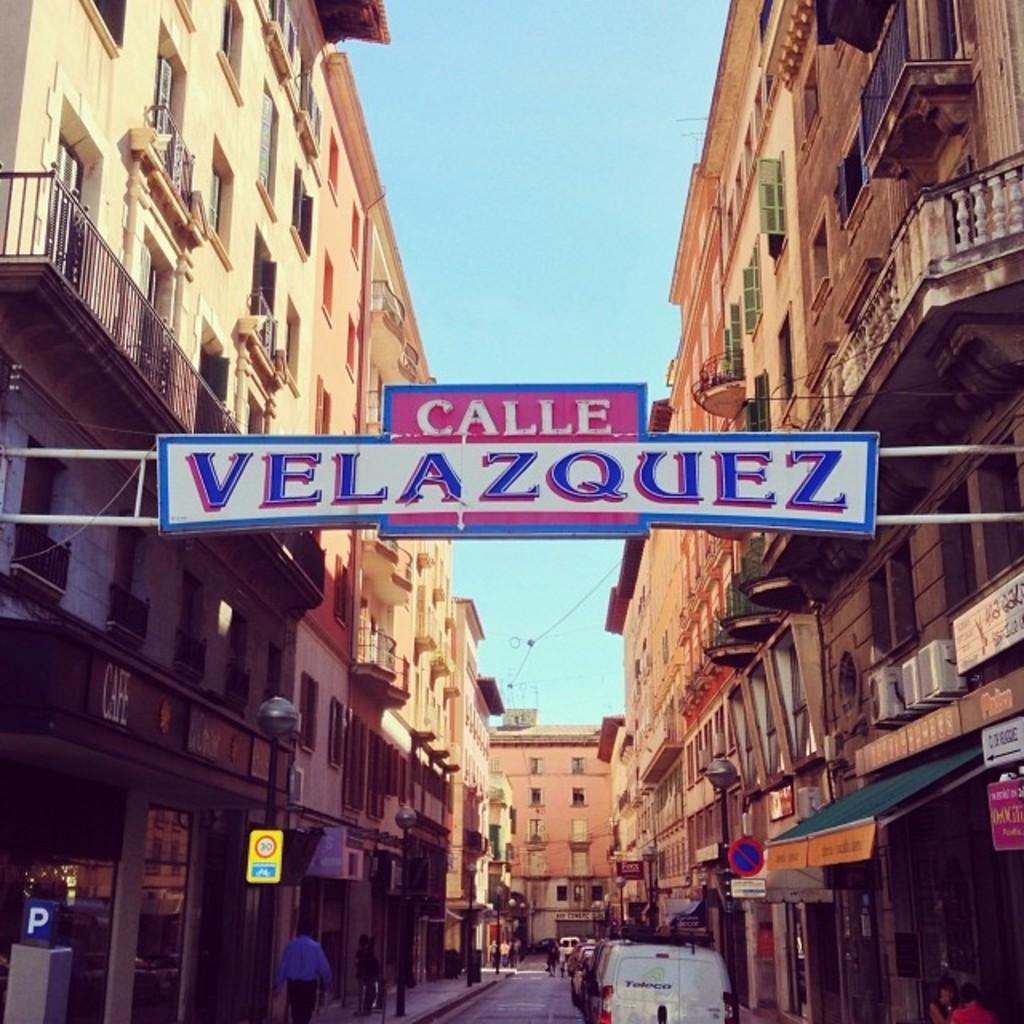What is located in the middle of the image? There is a board in the middle of the image. What can be seen on the board? There is text on the board. What architectural feature is present in the middle of the image? There is an arch in the middle of the image. What can be seen in the background of the image? Buildings, vehicles, people, street lights, sign boards, a road, and the sky are visible in the background of the image. What type of oatmeal is being served in the image? There is no oatmeal present in the image. Can you describe the haircut of the person in the image? There are no people close enough to see their haircut in the image. 